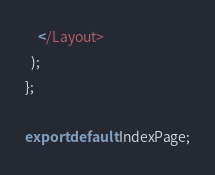<code> <loc_0><loc_0><loc_500><loc_500><_TypeScript_>    </Layout>
  );
};

export default IndexPage;
</code> 